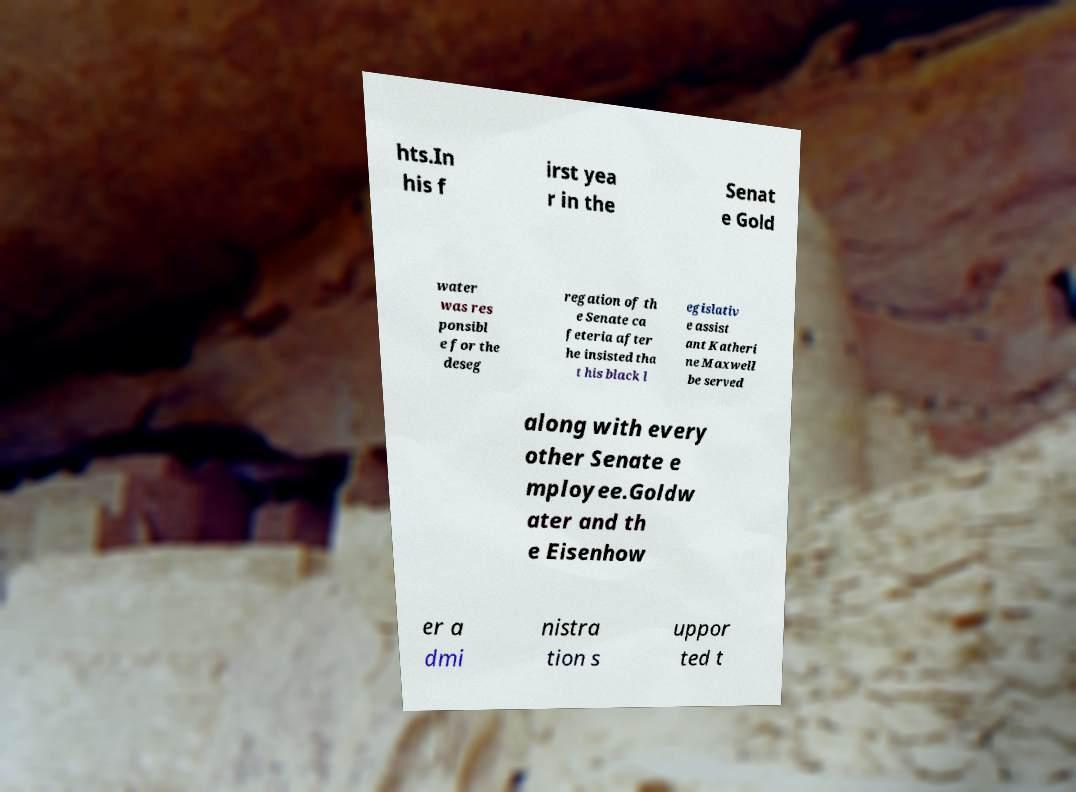There's text embedded in this image that I need extracted. Can you transcribe it verbatim? hts.In his f irst yea r in the Senat e Gold water was res ponsibl e for the deseg regation of th e Senate ca feteria after he insisted tha t his black l egislativ e assist ant Katheri ne Maxwell be served along with every other Senate e mployee.Goldw ater and th e Eisenhow er a dmi nistra tion s uppor ted t 